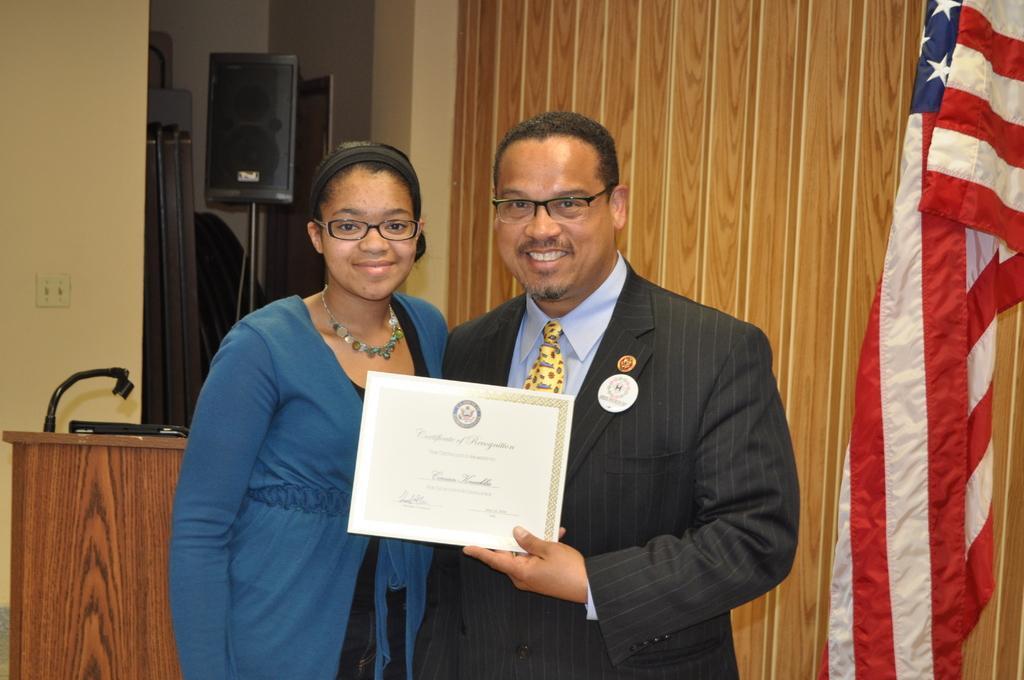Describe this image in one or two sentences. In this picture we can see there are two people standing and smiling. A man is holding a certificate and on the right side of the people there is a flag and behind the people there is a podium, wooden wall and a speaker with the stand and on the wall there is a switchboard. 